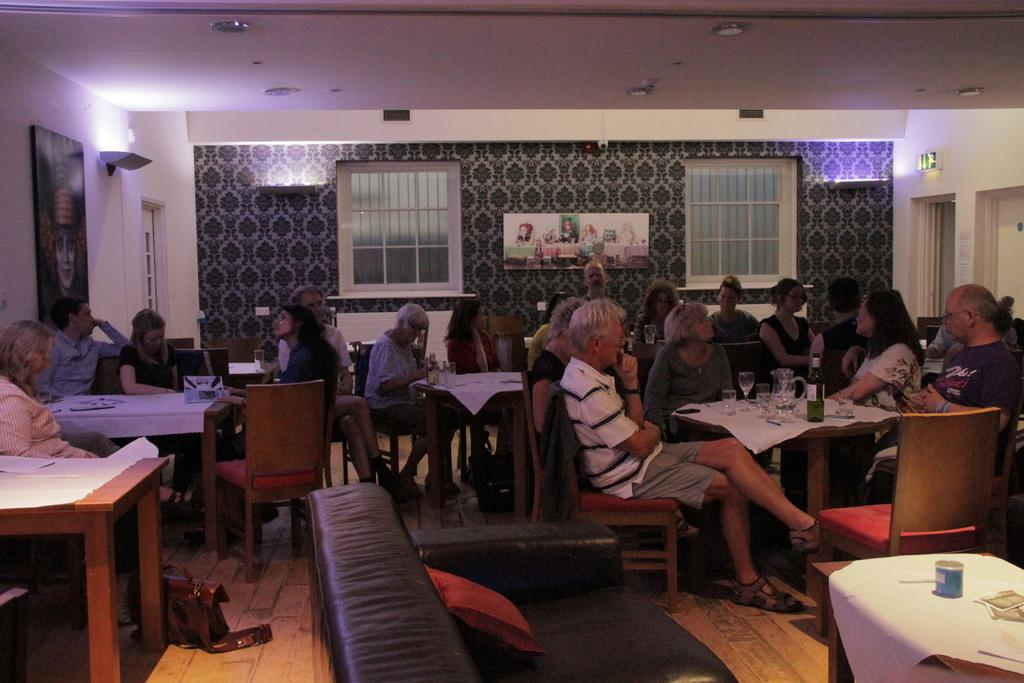How many people are in the image? There is a group of people in the image. What are the people doing in the image? The people are sitting on chairs. How are the chairs arranged in the image? The chairs are arranged around a table. What type of setting is depicted in the image? The setting appears to be a bar area. What type of secretary is sitting next to the person wearing a skirt in the image? There is no secretary or person wearing a skirt present in the image. 